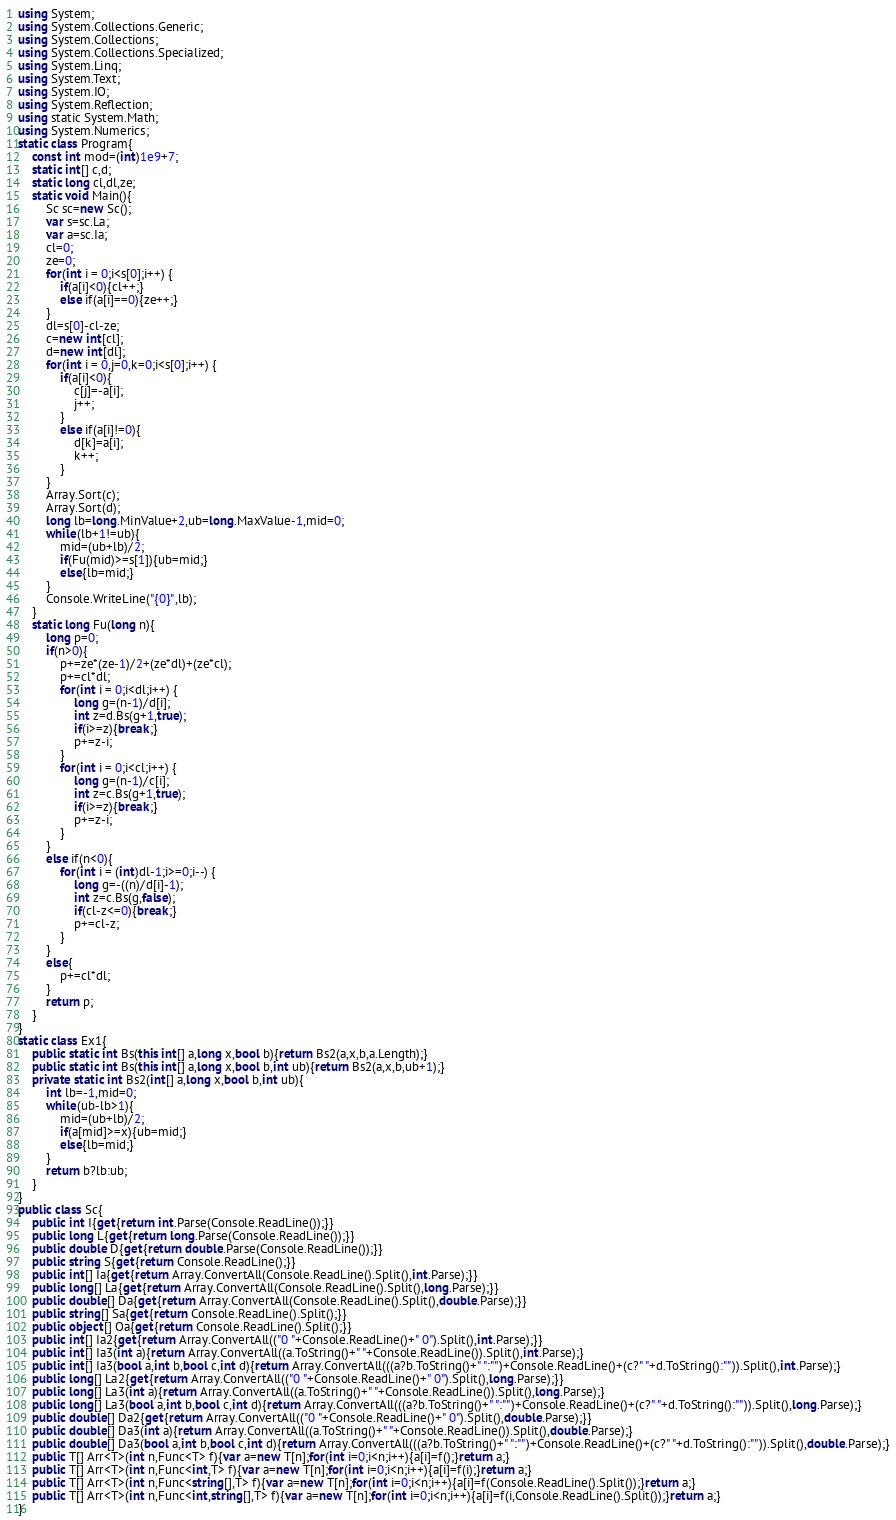<code> <loc_0><loc_0><loc_500><loc_500><_C#_>using System;
using System.Collections.Generic;
using System.Collections;
using System.Collections.Specialized;
using System.Linq;
using System.Text;
using System.IO;
using System.Reflection;
using static System.Math;
using System.Numerics;
static class Program{
	const int mod=(int)1e9+7;
	static int[] c,d;
	static long cl,dl,ze;
	static void Main(){
		Sc sc=new Sc();
		var s=sc.La;
		var a=sc.Ia;
		cl=0;
		ze=0;
		for(int i = 0;i<s[0];i++) {
			if(a[i]<0){cl++;}
			else if(a[i]==0){ze++;}
		}
		dl=s[0]-cl-ze;
		c=new int[cl];
		d=new int[dl];
		for(int i = 0,j=0,k=0;i<s[0];i++) {
			if(a[i]<0){
				c[j]=-a[i];
				j++;
			}
			else if(a[i]!=0){
				d[k]=a[i];
				k++;
			}
		}
		Array.Sort(c);
		Array.Sort(d);
		long lb=long.MinValue+2,ub=long.MaxValue-1,mid=0;
		while(lb+1!=ub){
			mid=(ub+lb)/2;
			if(Fu(mid)>=s[1]){ub=mid;}
			else{lb=mid;}
		}
		Console.WriteLine("{0}",lb);
	}
	static long Fu(long n){
		long p=0;
		if(n>0){
			p+=ze*(ze-1)/2+(ze*dl)+(ze*cl);
			p+=cl*dl;
			for(int i = 0;i<dl;i++) {
				long g=(n-1)/d[i];
				int z=d.Bs(g+1,true);
				if(i>=z){break;}
				p+=z-i;
			}
			for(int i = 0;i<cl;i++) {
				long g=(n-1)/c[i];
				int z=c.Bs(g+1,true);
				if(i>=z){break;}
				p+=z-i;
			}
		}
		else if(n<0){
			for(int i = (int)dl-1;i>=0;i--) {
				long g=-((n)/d[i]-1);
				int z=c.Bs(g,false);
				if(cl-z<=0){break;}
				p+=cl-z;
			}
		}
		else{
			p+=cl*dl;
		}
		return p;
	}
}
static class Ex1{
	public static int Bs(this int[] a,long x,bool b){return Bs2(a,x,b,a.Length);}
	public static int Bs(this int[] a,long x,bool b,int ub){return Bs2(a,x,b,ub+1);}
	private static int Bs2(int[] a,long x,bool b,int ub){
		int lb=-1,mid=0;
		while(ub-lb>1){
			mid=(ub+lb)/2;
			if(a[mid]>=x){ub=mid;}
			else{lb=mid;}
		}
		return b?lb:ub;
	}
}
public class Sc{
	public int I{get{return int.Parse(Console.ReadLine());}}
	public long L{get{return long.Parse(Console.ReadLine());}}
	public double D{get{return double.Parse(Console.ReadLine());}}
	public string S{get{return Console.ReadLine();}}
	public int[] Ia{get{return Array.ConvertAll(Console.ReadLine().Split(),int.Parse);}}
	public long[] La{get{return Array.ConvertAll(Console.ReadLine().Split(),long.Parse);}}
	public double[] Da{get{return Array.ConvertAll(Console.ReadLine().Split(),double.Parse);}}
	public string[] Sa{get{return Console.ReadLine().Split();}}
	public object[] Oa{get{return Console.ReadLine().Split();}}
	public int[] Ia2{get{return Array.ConvertAll(("0 "+Console.ReadLine()+" 0").Split(),int.Parse);}}
	public int[] Ia3(int a){return Array.ConvertAll((a.ToString()+" "+Console.ReadLine()).Split(),int.Parse);}
	public int[] Ia3(bool a,int b,bool c,int d){return Array.ConvertAll(((a?b.ToString()+" ":"")+Console.ReadLine()+(c?" "+d.ToString():"")).Split(),int.Parse);}
	public long[] La2{get{return Array.ConvertAll(("0 "+Console.ReadLine()+" 0").Split(),long.Parse);}}
	public long[] La3(int a){return Array.ConvertAll((a.ToString()+" "+Console.ReadLine()).Split(),long.Parse);}
	public long[] La3(bool a,int b,bool c,int d){return Array.ConvertAll(((a?b.ToString()+" ":"")+Console.ReadLine()+(c?" "+d.ToString():"")).Split(),long.Parse);}
	public double[] Da2{get{return Array.ConvertAll(("0 "+Console.ReadLine()+" 0").Split(),double.Parse);}}
	public double[] Da3(int a){return Array.ConvertAll((a.ToString()+" "+Console.ReadLine()).Split(),double.Parse);}
	public double[] Da3(bool a,int b,bool c,int d){return Array.ConvertAll(((a?b.ToString()+" ":"")+Console.ReadLine()+(c?" "+d.ToString():"")).Split(),double.Parse);}
	public T[] Arr<T>(int n,Func<T> f){var a=new T[n];for(int i=0;i<n;i++){a[i]=f();}return a;}
	public T[] Arr<T>(int n,Func<int,T> f){var a=new T[n];for(int i=0;i<n;i++){a[i]=f(i);}return a;}
	public T[] Arr<T>(int n,Func<string[],T> f){var a=new T[n];for(int i=0;i<n;i++){a[i]=f(Console.ReadLine().Split());}return a;}
	public T[] Arr<T>(int n,Func<int,string[],T> f){var a=new T[n];for(int i=0;i<n;i++){a[i]=f(i,Console.ReadLine().Split());}return a;}
}</code> 